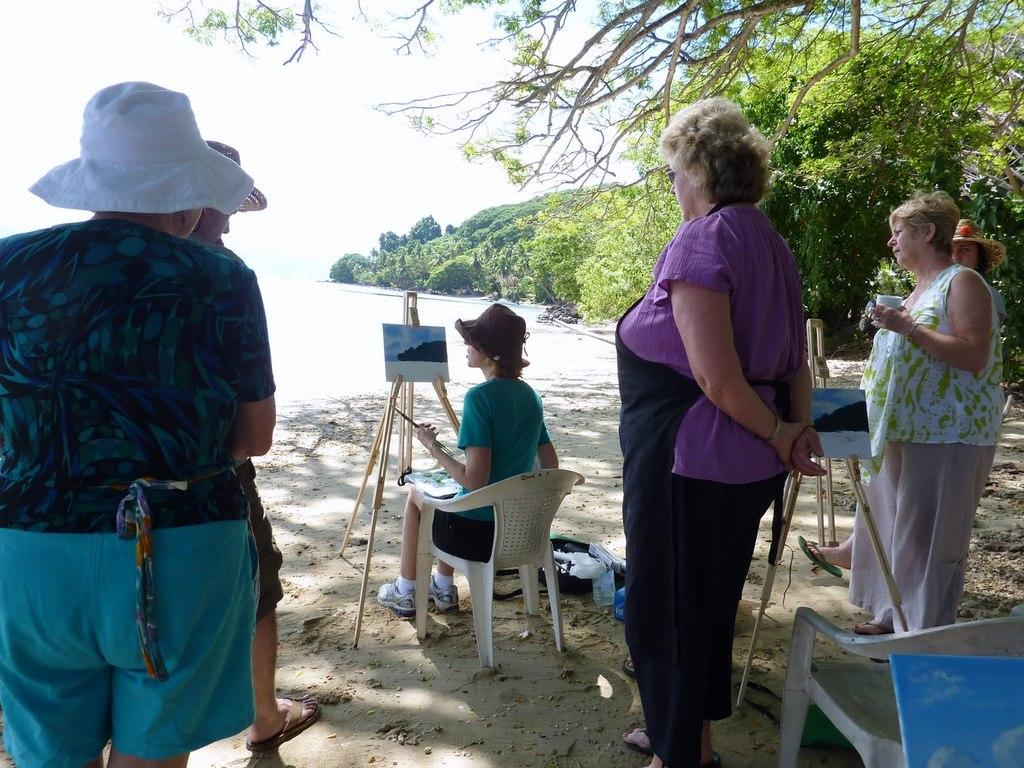What can be seen in the background of the image? There is a sky in the image. What is happening in the foreground of the image? There are people standing in the image. Can you describe the position of the woman in the image? There is a woman sitting on a chair in the image. What type of cast is visible on the woman's leg in the image? There is no cast visible on the woman's leg in the image; she is simply sitting on a chair. What scientific experiment is being conducted in the image? There is no scientific experiment being conducted in the image; it features people standing and a woman sitting on a chair. 